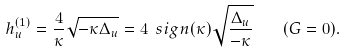Convert formula to latex. <formula><loc_0><loc_0><loc_500><loc_500>h _ { u } ^ { ( 1 ) } = \frac { 4 } { \kappa } \sqrt { - \kappa \Delta _ { u } } = 4 \ s i g n ( \kappa ) \sqrt { \frac { \Delta _ { u } } { - \kappa } } \quad ( G = 0 ) .</formula> 